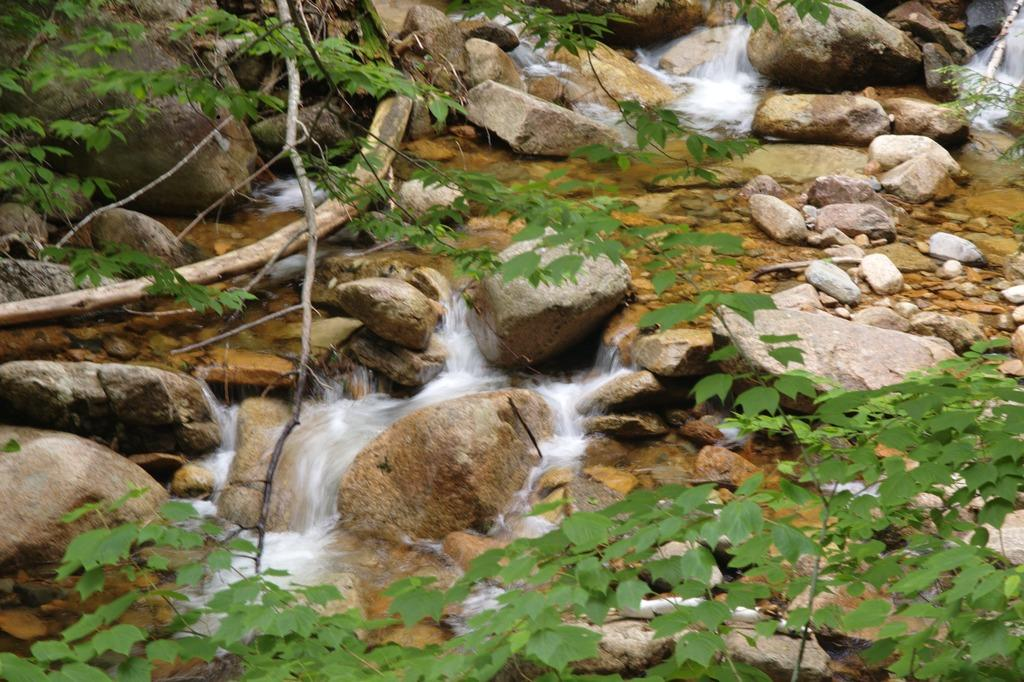What is the primary element visible in the image? There is water in the image. What type of vegetation can be seen in the image? There are plants in the image. What other objects are present in the image? There are rocks in the image. What type of sweater is being worn by the plants in the image? There are no people or clothing items present in the image, as it features water, plants, and rocks. 